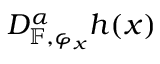Convert formula to latex. <formula><loc_0><loc_0><loc_500><loc_500>D _ { \mathbb { F } , \varphi _ { x } } ^ { \alpha } h ( x )</formula> 